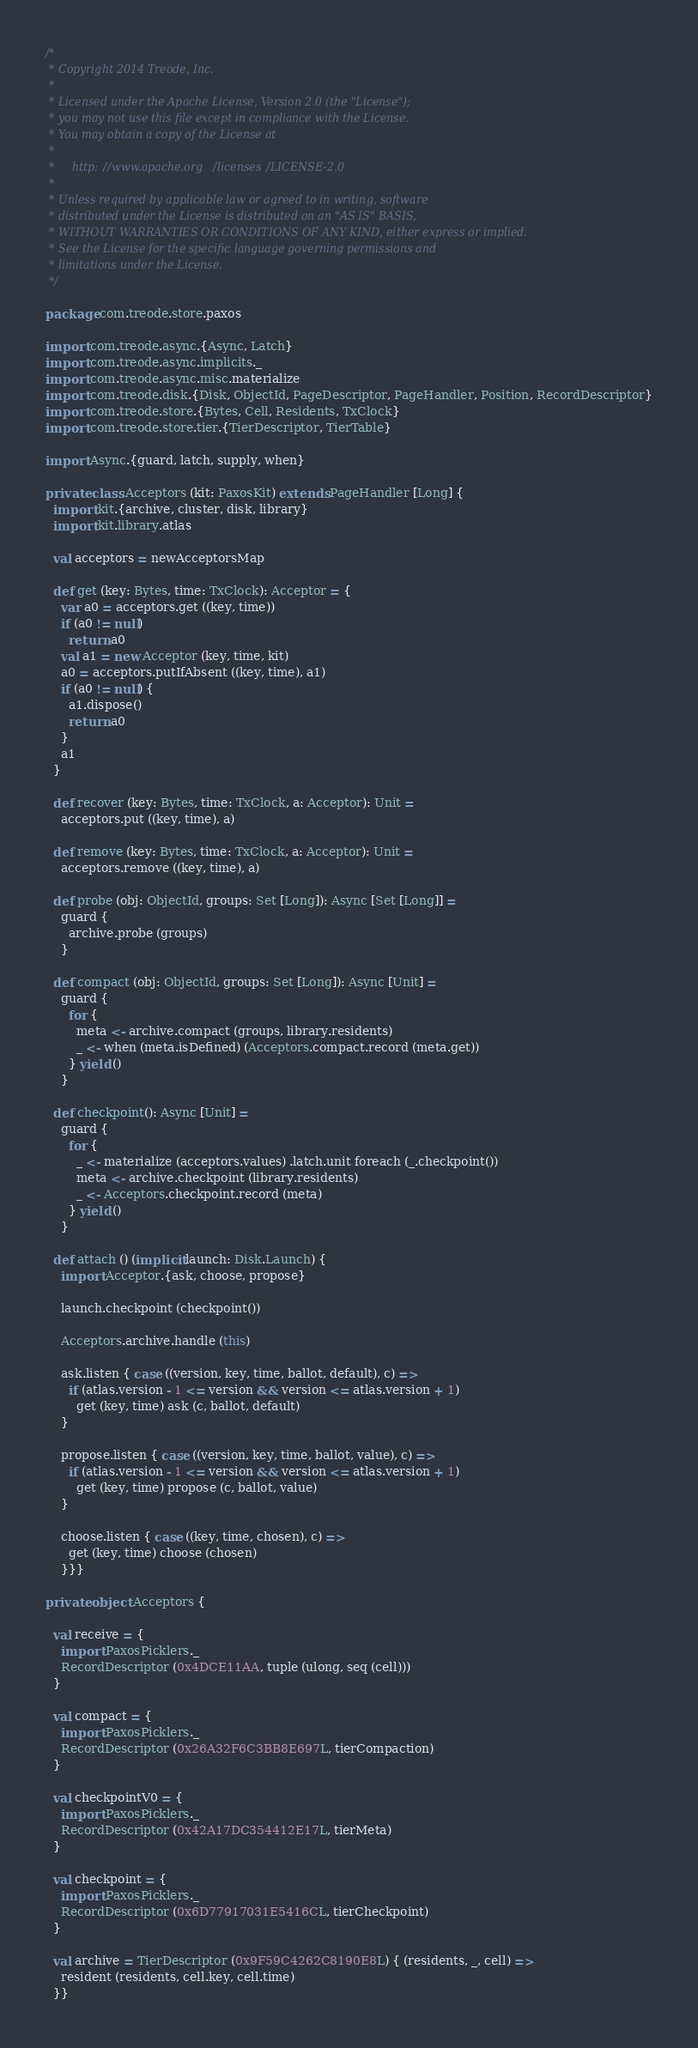<code> <loc_0><loc_0><loc_500><loc_500><_Scala_>/*
 * Copyright 2014 Treode, Inc.
 *
 * Licensed under the Apache License, Version 2.0 (the "License");
 * you may not use this file except in compliance with the License.
 * You may obtain a copy of the License at
 *
 *     http://www.apache.org/licenses/LICENSE-2.0
 *
 * Unless required by applicable law or agreed to in writing, software
 * distributed under the License is distributed on an "AS IS" BASIS,
 * WITHOUT WARRANTIES OR CONDITIONS OF ANY KIND, either express or implied.
 * See the License for the specific language governing permissions and
 * limitations under the License.
 */

package com.treode.store.paxos

import com.treode.async.{Async, Latch}
import com.treode.async.implicits._
import com.treode.async.misc.materialize
import com.treode.disk.{Disk, ObjectId, PageDescriptor, PageHandler, Position, RecordDescriptor}
import com.treode.store.{Bytes, Cell, Residents, TxClock}
import com.treode.store.tier.{TierDescriptor, TierTable}

import Async.{guard, latch, supply, when}

private class Acceptors (kit: PaxosKit) extends PageHandler [Long] {
  import kit.{archive, cluster, disk, library}
  import kit.library.atlas

  val acceptors = newAcceptorsMap

  def get (key: Bytes, time: TxClock): Acceptor = {
    var a0 = acceptors.get ((key, time))
    if (a0 != null)
      return a0
    val a1 = new Acceptor (key, time, kit)
    a0 = acceptors.putIfAbsent ((key, time), a1)
    if (a0 != null) {
      a1.dispose()
      return a0
    }
    a1
  }

  def recover (key: Bytes, time: TxClock, a: Acceptor): Unit =
    acceptors.put ((key, time), a)

  def remove (key: Bytes, time: TxClock, a: Acceptor): Unit =
    acceptors.remove ((key, time), a)

  def probe (obj: ObjectId, groups: Set [Long]): Async [Set [Long]] =
    guard {
      archive.probe (groups)
    }

  def compact (obj: ObjectId, groups: Set [Long]): Async [Unit] =
    guard {
      for {
        meta <- archive.compact (groups, library.residents)
        _ <- when (meta.isDefined) (Acceptors.compact.record (meta.get))
      } yield ()
    }

  def checkpoint(): Async [Unit] =
    guard {
      for {
        _ <- materialize (acceptors.values) .latch.unit foreach (_.checkpoint())
        meta <- archive.checkpoint (library.residents)
        _ <- Acceptors.checkpoint.record (meta)
      } yield ()
    }

  def attach () (implicit launch: Disk.Launch) {
    import Acceptor.{ask, choose, propose}

    launch.checkpoint (checkpoint())

    Acceptors.archive.handle (this)

    ask.listen { case ((version, key, time, ballot, default), c) =>
      if (atlas.version - 1 <= version && version <= atlas.version + 1)
        get (key, time) ask (c, ballot, default)
    }

    propose.listen { case ((version, key, time, ballot, value), c) =>
      if (atlas.version - 1 <= version && version <= atlas.version + 1)
        get (key, time) propose (c, ballot, value)
    }

    choose.listen { case ((key, time, chosen), c) =>
      get (key, time) choose (chosen)
    }}}

private object Acceptors {

  val receive = {
    import PaxosPicklers._
    RecordDescriptor (0x4DCE11AA, tuple (ulong, seq (cell)))
  }

  val compact = {
    import PaxosPicklers._
    RecordDescriptor (0x26A32F6C3BB8E697L, tierCompaction)
  }

  val checkpointV0 = {
    import PaxosPicklers._
    RecordDescriptor (0x42A17DC354412E17L, tierMeta)
  }

  val checkpoint = {
    import PaxosPicklers._
    RecordDescriptor (0x6D77917031E5416CL, tierCheckpoint)
  }

  val archive = TierDescriptor (0x9F59C4262C8190E8L) { (residents, _, cell) =>
    resident (residents, cell.key, cell.time)
  }}
</code> 